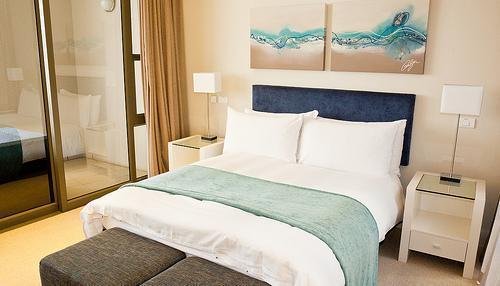How many pillows are there?
Give a very brief answer. 4. 